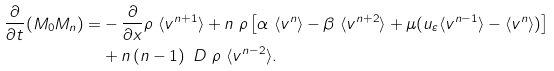Convert formula to latex. <formula><loc_0><loc_0><loc_500><loc_500>\frac { \partial } { \partial t } ( M _ { 0 } M _ { n } ) = & - \frac { \partial } { \partial x } \rho \ \langle v ^ { n + 1 } \rangle + n \ \rho \left [ \alpha \ \langle v ^ { n } \rangle - \beta \ \langle v ^ { n + 2 } \rangle + \mu ( u _ { \varepsilon } \langle v ^ { n - 1 } \rangle - \langle v ^ { n } \rangle ) \right ] \\ & + n \left ( n - 1 \right ) \ D \ \rho \ \langle v ^ { n - 2 } \rangle .</formula> 